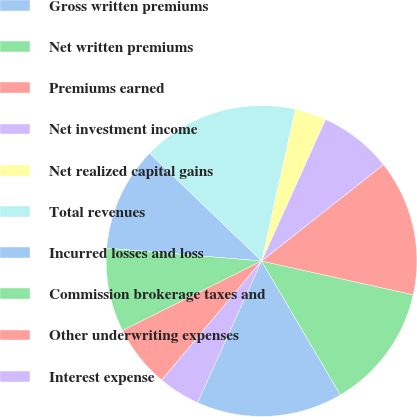Convert chart to OTSL. <chart><loc_0><loc_0><loc_500><loc_500><pie_chart><fcel>Gross written premiums<fcel>Net written premiums<fcel>Premiums earned<fcel>Net investment income<fcel>Net realized capital gains<fcel>Total revenues<fcel>Incurred losses and loss<fcel>Commission brokerage taxes and<fcel>Other underwriting expenses<fcel>Interest expense<nl><fcel>15.22%<fcel>13.04%<fcel>14.13%<fcel>7.61%<fcel>3.26%<fcel>16.3%<fcel>10.87%<fcel>8.7%<fcel>6.52%<fcel>4.35%<nl></chart> 